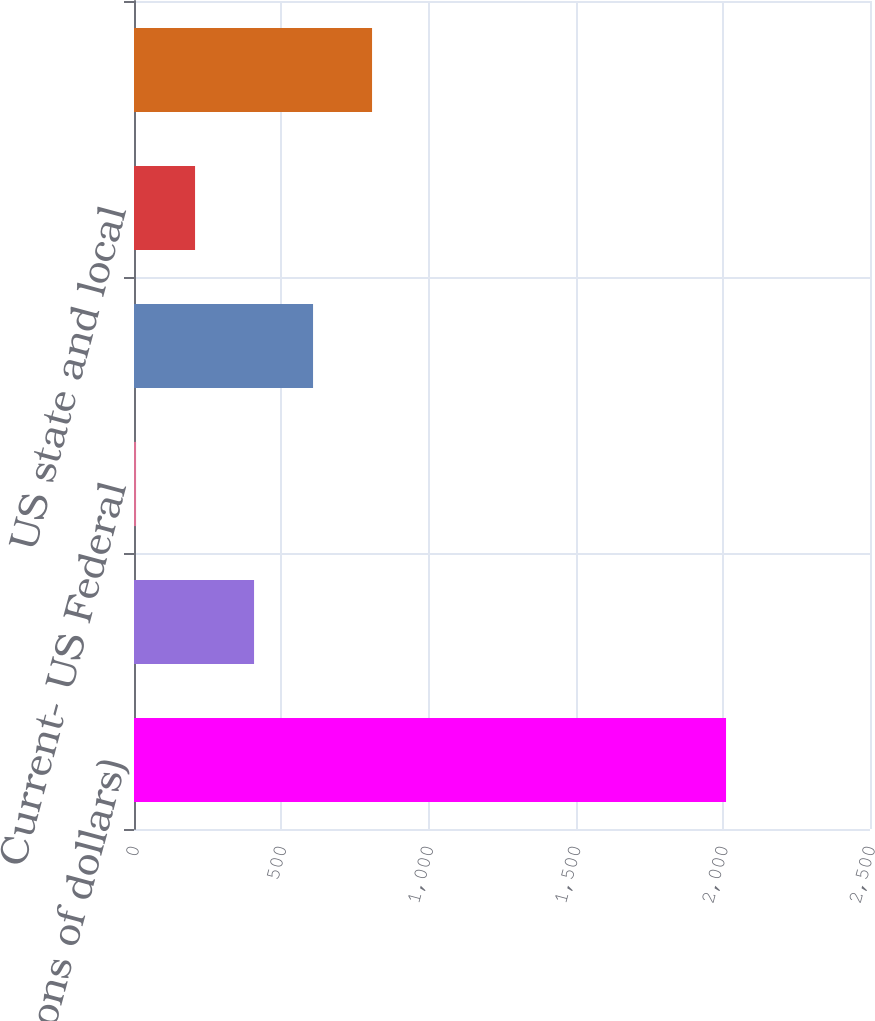Convert chart. <chart><loc_0><loc_0><loc_500><loc_500><bar_chart><fcel>(In millions of dollars)<fcel>US<fcel>Current- US Federal<fcel>Other national governments<fcel>US state and local<fcel>Total income taxes<nl><fcel>2011<fcel>407.8<fcel>7<fcel>608.2<fcel>207.4<fcel>808.6<nl></chart> 